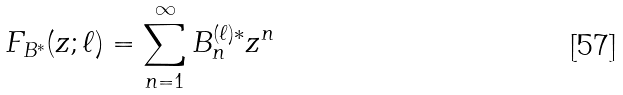<formula> <loc_0><loc_0><loc_500><loc_500>F _ { B ^ { * } } ( z ; \ell ) = \sum _ { n = 1 } ^ { \infty } B _ { n } ^ { ( \ell ) * } z ^ { n }</formula> 